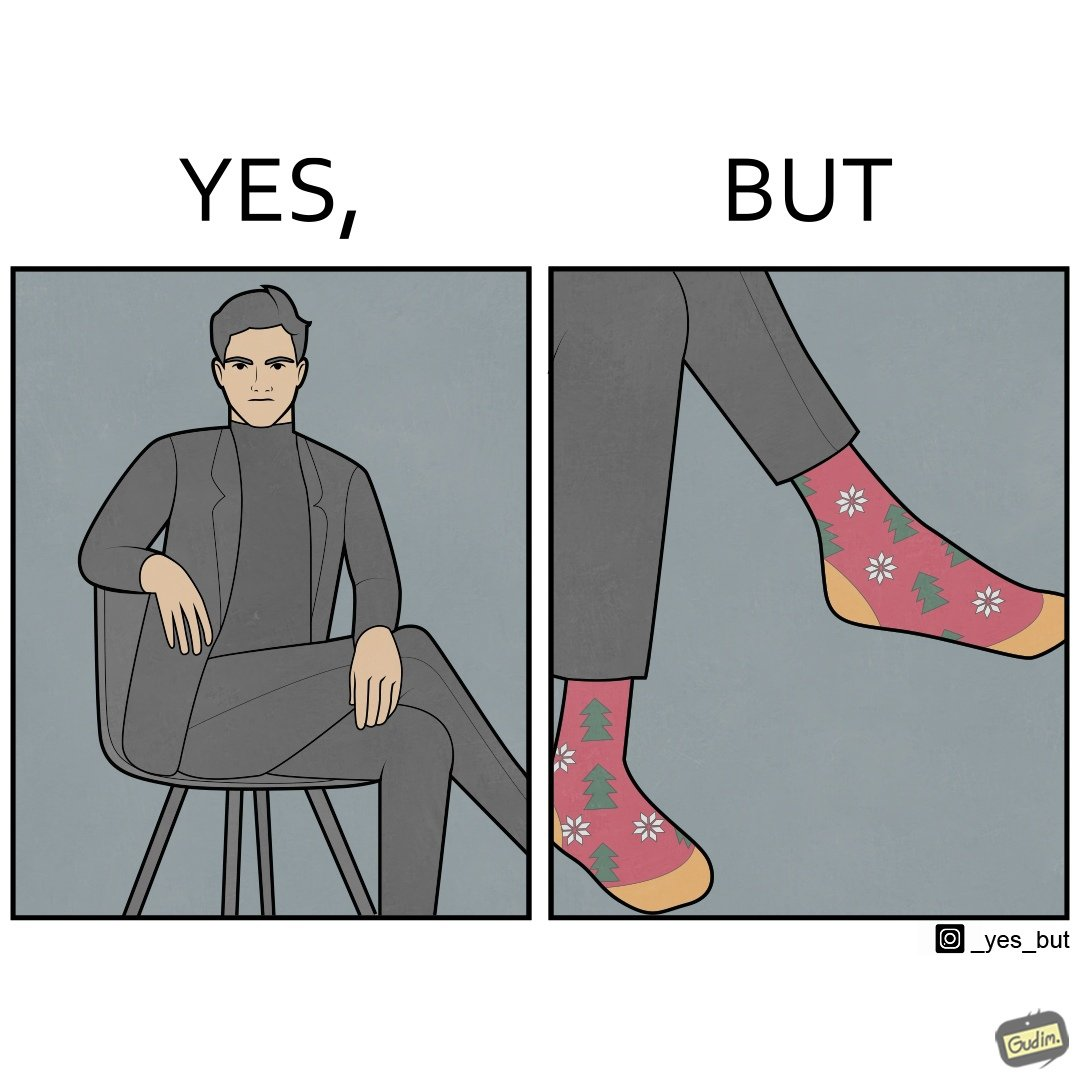What do you see in each half of this image? In the left part of the image: A person in black formal suit and pants In the right part of the image: Legs of a person with black pants, and colorful socks with flowers and trees drawn on it. 